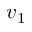Convert formula to latex. <formula><loc_0><loc_0><loc_500><loc_500>v _ { 1 }</formula> 